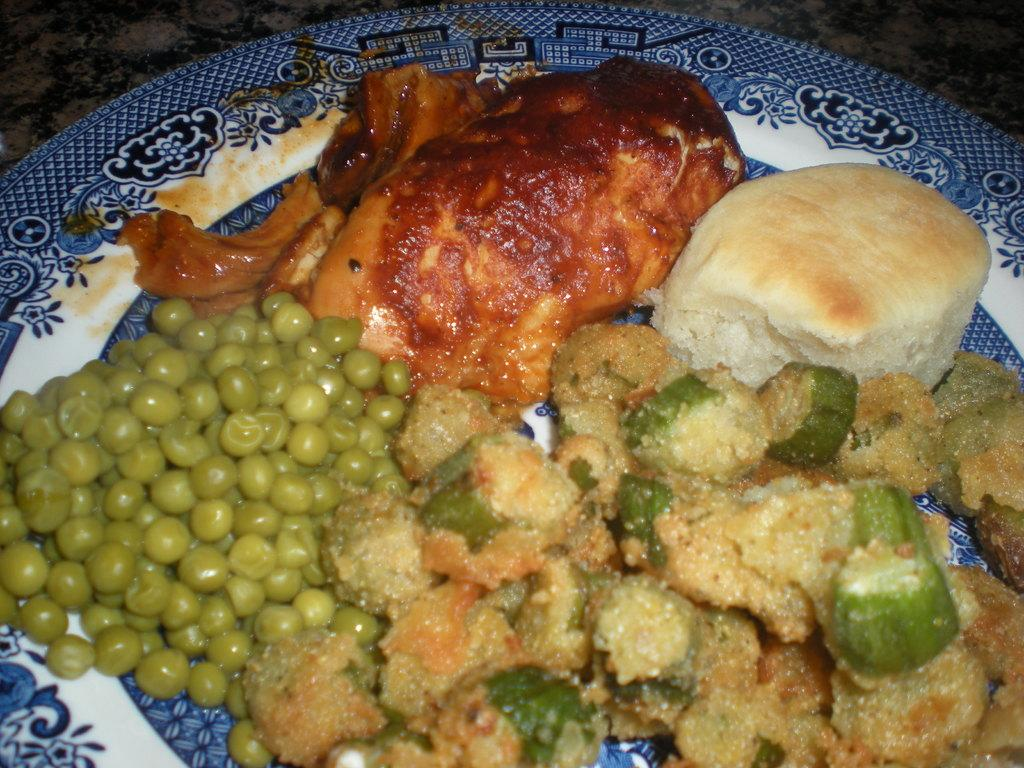What types of food can be seen on the plate in the image? There is meat, bread, beans, and vegetable curry on the plate in the image. Can you describe the different components of the meal? The plate contains meat, bread, beans, and vegetable curry. What type of dish might this meal be part of? This meal could be part of a balanced meal, such as a lunch or dinner. What type of bait is used to catch fish in the image? There is no bait or fishing activity present in the image. How many kittens are playing with the cord in the image? There are no kittens or cords present in the image. 